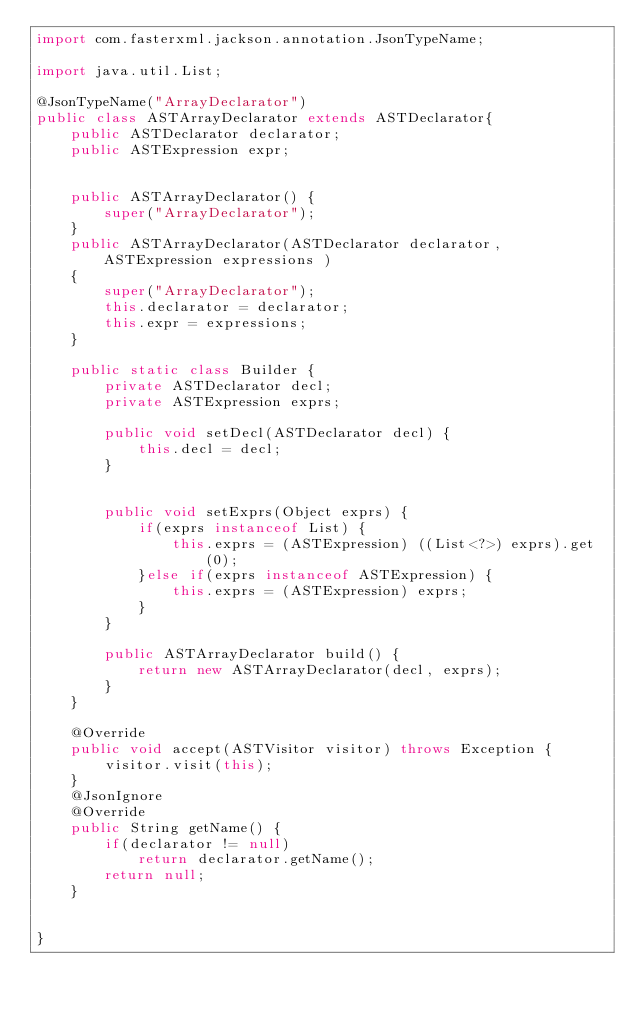<code> <loc_0><loc_0><loc_500><loc_500><_Java_>import com.fasterxml.jackson.annotation.JsonTypeName;

import java.util.List;

@JsonTypeName("ArrayDeclarator")
public class ASTArrayDeclarator extends ASTDeclarator{
	public ASTDeclarator declarator;
	public ASTExpression expr;
	
	
	public ASTArrayDeclarator() {
		super("ArrayDeclarator");
	}
	public ASTArrayDeclarator(ASTDeclarator declarator, ASTExpression expressions )
	{
		super("ArrayDeclarator");
		this.declarator = declarator;
		this.expr = expressions;
	}
	
	public static class Builder {
		private ASTDeclarator decl;
		private ASTExpression exprs;
		
		public void setDecl(ASTDeclarator decl) {
			this.decl = decl;
		}
		
		
		public void setExprs(Object exprs) {
			if(exprs instanceof List) {
				this.exprs = (ASTExpression) ((List<?>) exprs).get(0);
			}else if(exprs instanceof ASTExpression) {
				this.exprs = (ASTExpression) exprs;
			}
		}
		
		public ASTArrayDeclarator build() {
			return new ASTArrayDeclarator(decl, exprs);
		}
	}
	
	@Override
	public void accept(ASTVisitor visitor) throws Exception {
		visitor.visit(this);
	}
	@JsonIgnore
	@Override
	public String getName() {
		if(declarator != null)
			return declarator.getName();
		return null;
	}


}
</code> 